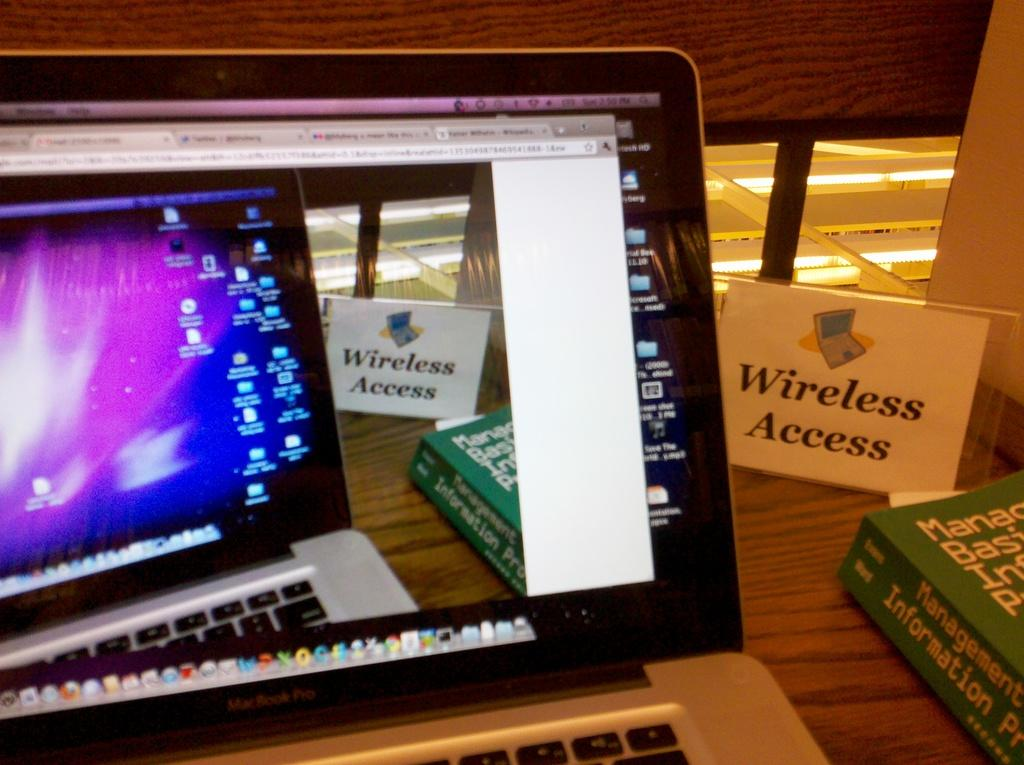Provide a one-sentence caption for the provided image. an open lap top computer next to a Wireless Access sign. 